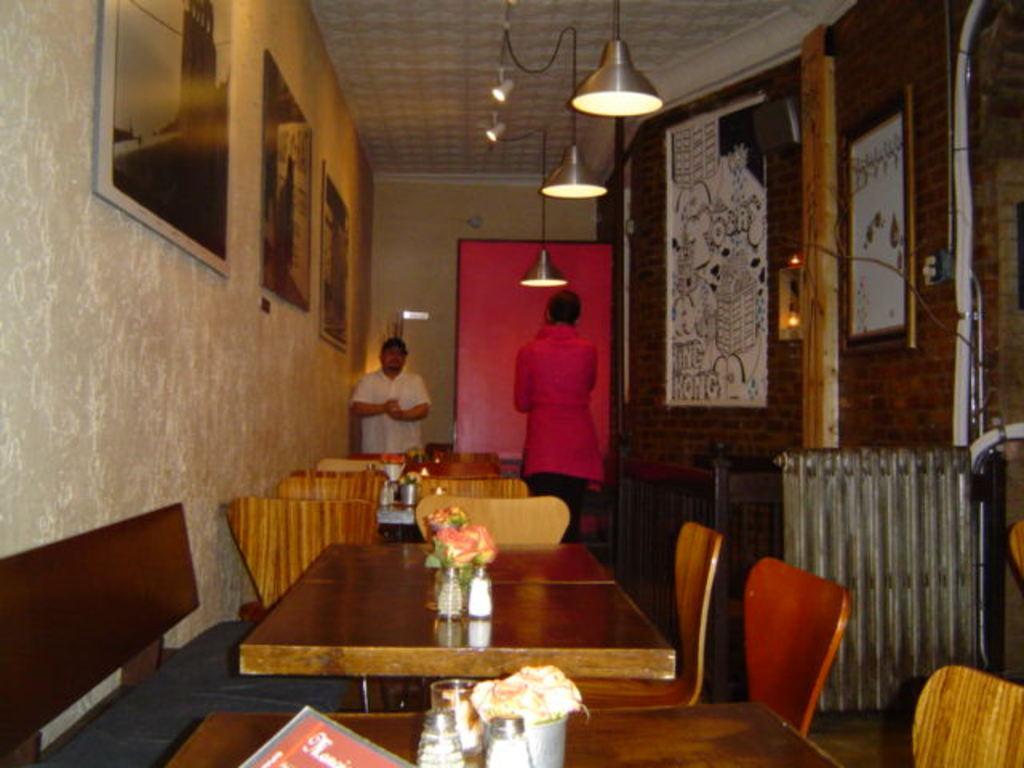Please provide a concise description of this image. The image is taken in the restaurant. In the center of the image there are tables. There are two people standing in the image. On the left side there are wall frames which are attached to the wall. On the right there is a brick wall. At the top there are lights which are attached to the roof. In the background there is a door. 